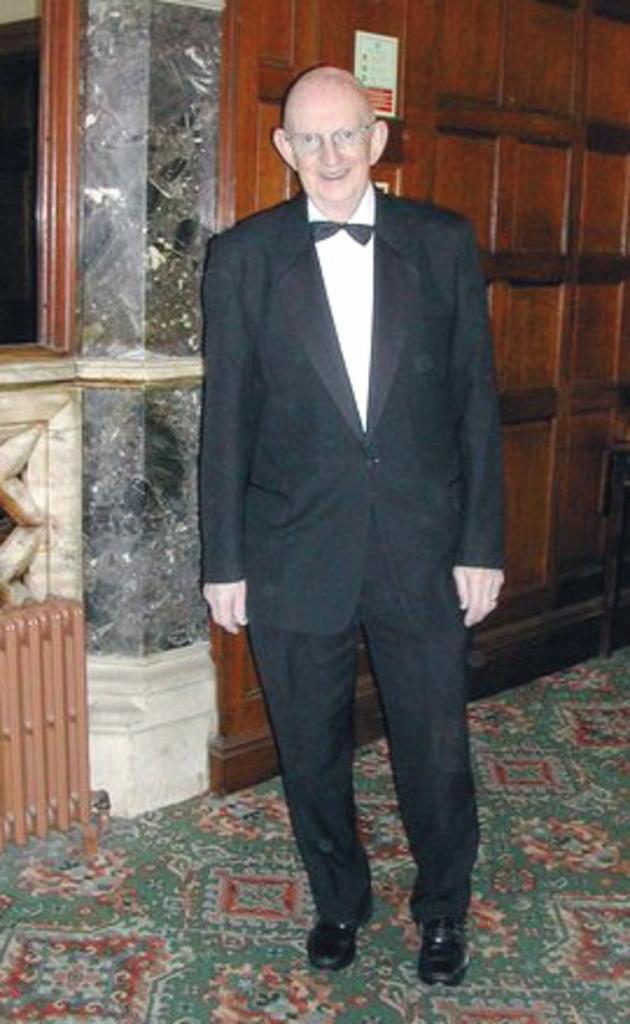Could you give a brief overview of what you see in this image? In this image, there is a person wearing clothes and standing in front of the wall. 